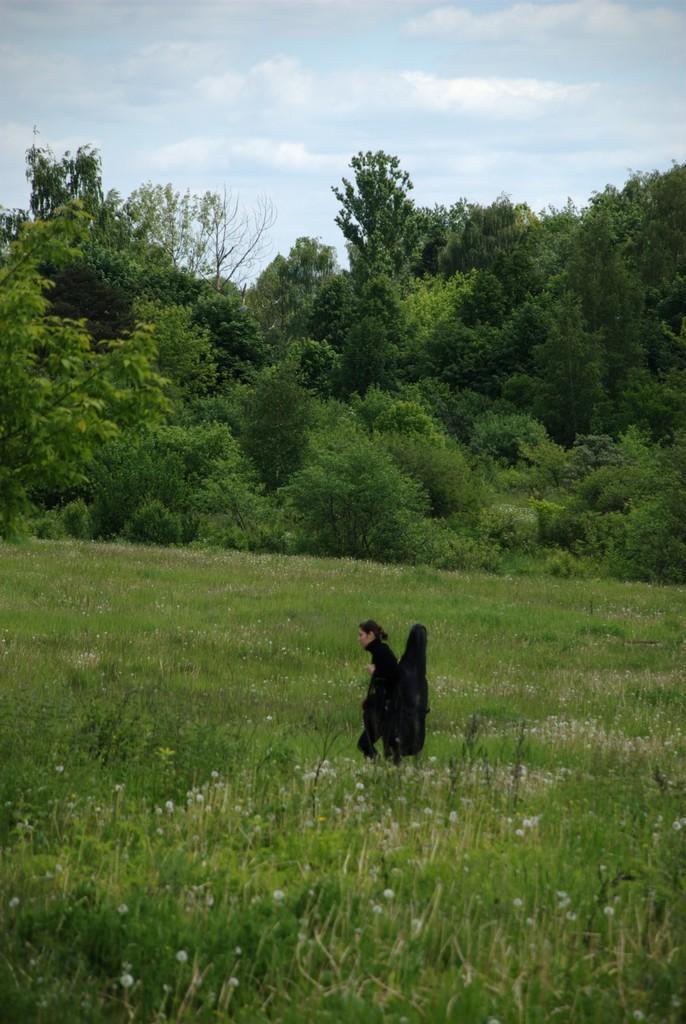How would you summarize this image in a sentence or two? There is a lady holding a bag and walking through the plants. In the background there are trees and sky. 